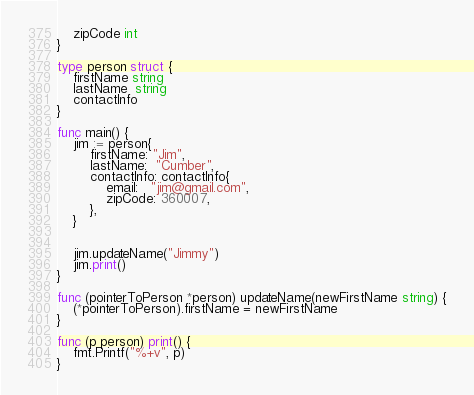<code> <loc_0><loc_0><loc_500><loc_500><_Go_>	zipCode int
}

type person struct {
	firstName string
	lastName  string
	contactInfo
}

func main() {
	jim := person{
		firstName: "Jim",
		lastName:  "Cumber",
		contactInfo: contactInfo{
			email:   "jim@gmail.com",
			zipCode: 360007,
		},
	}

	
	jim.updateName("Jimmy")
	jim.print()
}

func (pointerToPerson *person) updateName(newFirstName string) {
	(*pointerToPerson).firstName = newFirstName
}

func (p person) print() {
	fmt.Printf("%+v", p)
}
</code> 